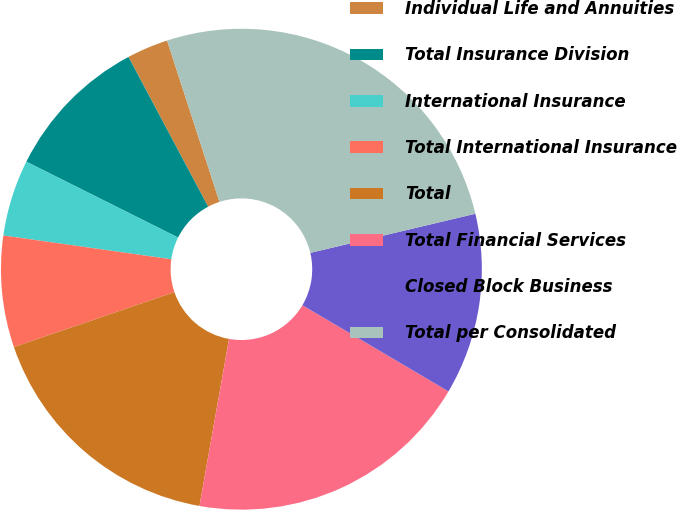Convert chart. <chart><loc_0><loc_0><loc_500><loc_500><pie_chart><fcel>Individual Life and Annuities<fcel>Total Insurance Division<fcel>International Insurance<fcel>Total International Insurance<fcel>Total<fcel>Total Financial Services<fcel>Closed Block Business<fcel>Total per Consolidated<nl><fcel>2.78%<fcel>9.84%<fcel>5.14%<fcel>7.49%<fcel>16.96%<fcel>19.31%<fcel>12.19%<fcel>26.3%<nl></chart> 